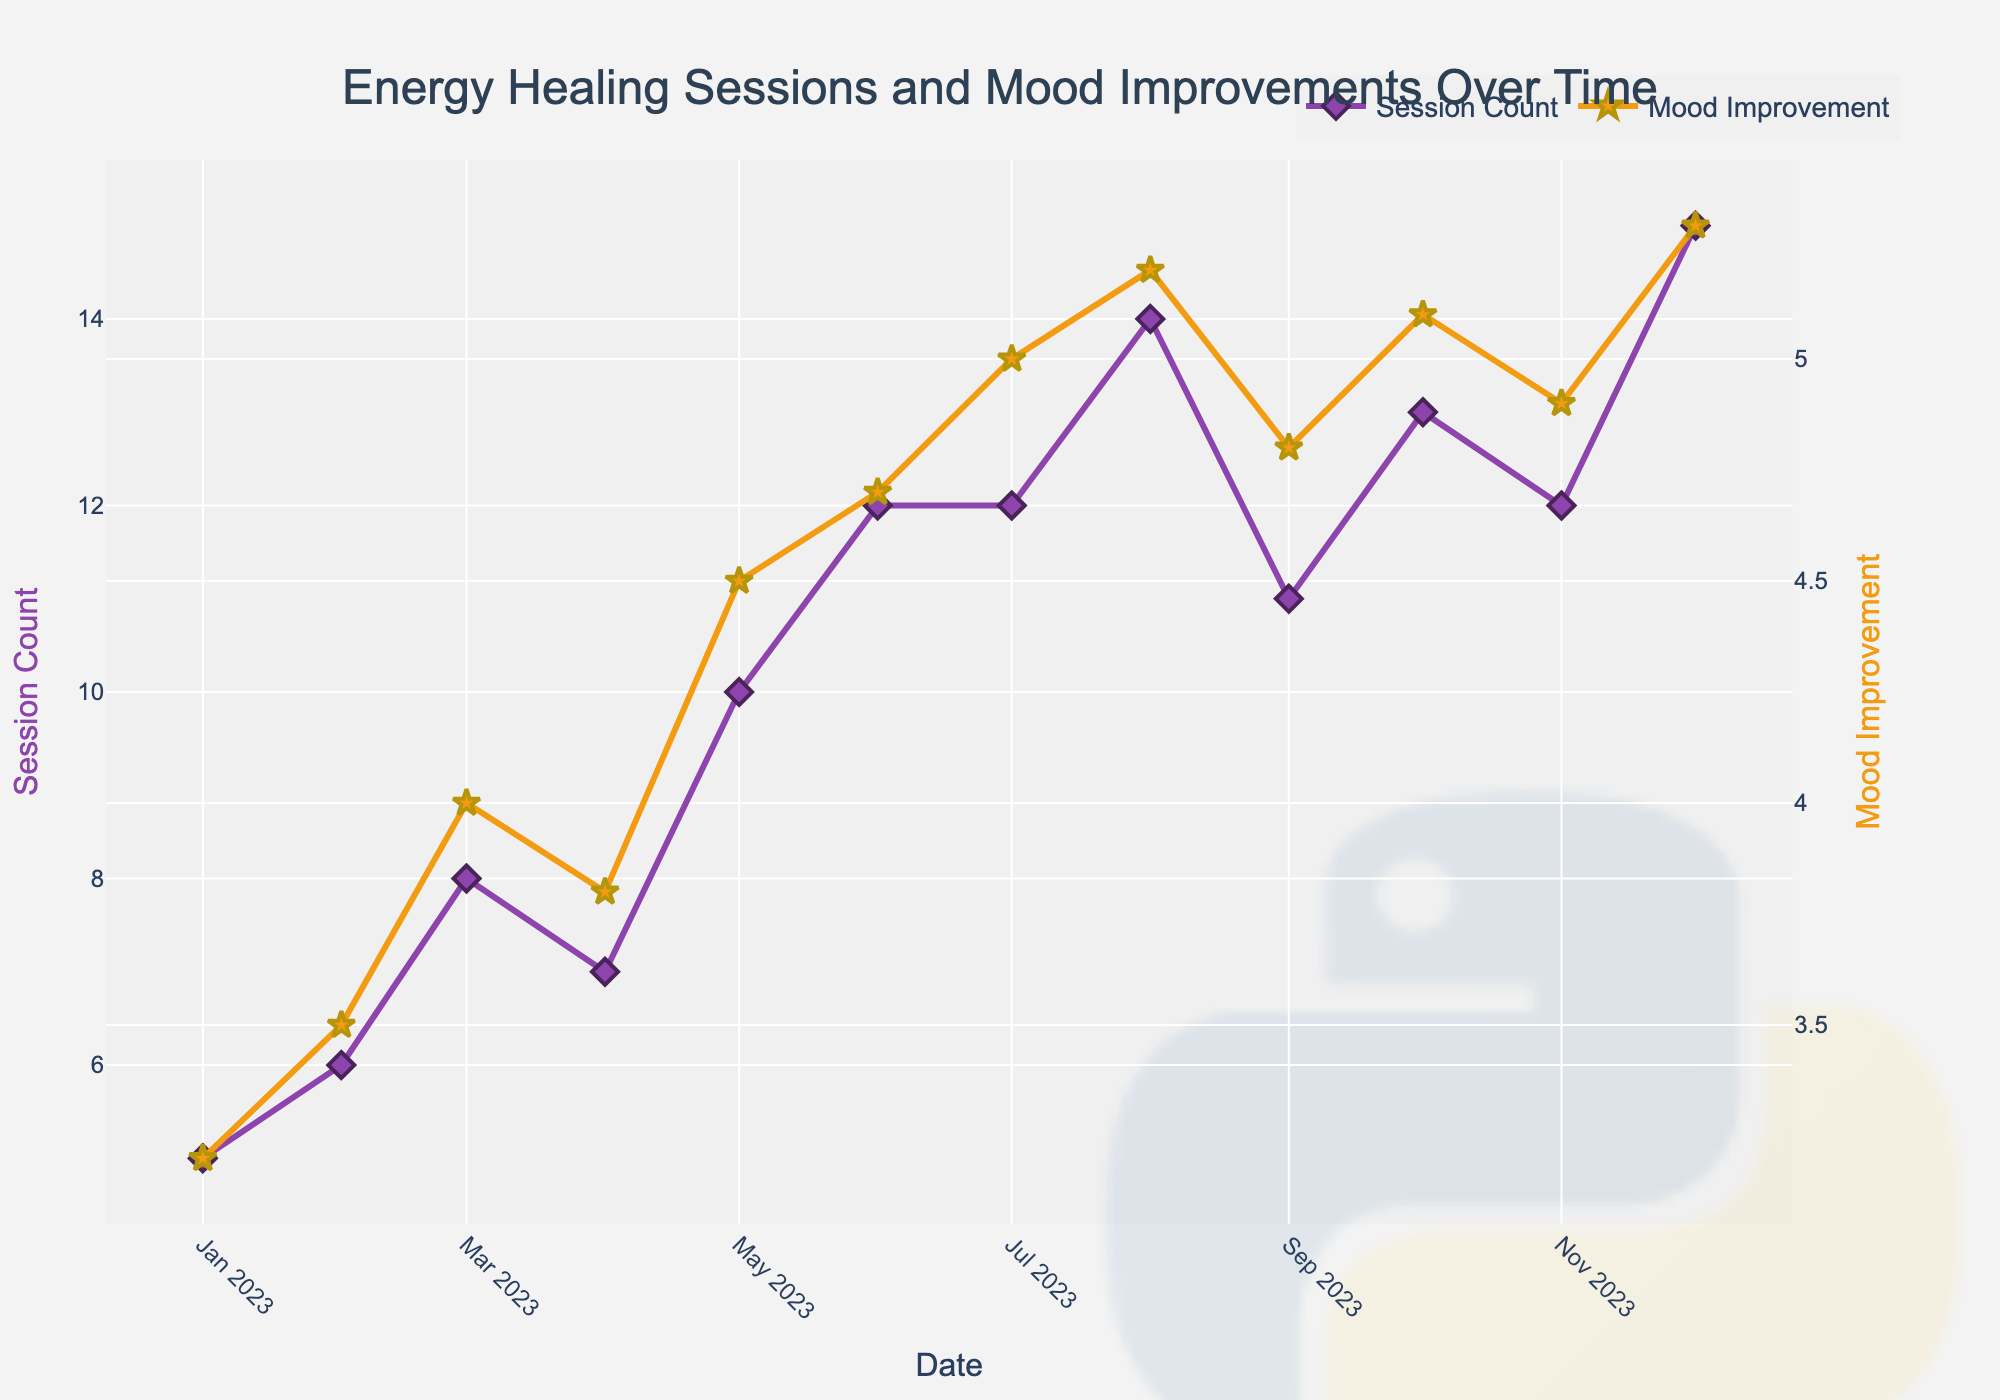How many data points are there in the plot? Count the number of data points on the x-axis (Date). Each month from January to December represents a data point.
Answer: 12 Which month has the highest session count? By observing the peaks on the Session Count line, it is apparent that December has the highest point.
Answer: December What is the title of the plot? The title is displayed at the top of the plot. It reads "Energy Healing Sessions and Mood Improvements Over Time."
Answer: Energy Healing Sessions and Mood Improvements Over Time What is the color of the line representing Mood Improvement? The Mood Improvement line is shown in a bright color distinct from Session Count, specifically in a shade of vibrant orange.
Answer: Orange What is the average mood improvement from June to December? Sum the Mood Improvement values from June (4.7), July (5.0), August (5.2), September (4.8), October (5.1), November (4.9), and December (5.3), then divide by the number of months (7). Calculation: (4.7 + 5.0 + 5.2 + 4.8 + 5.1 + 4.9 + 5.3) / 7 = 35 / 7 = 5.0
Answer: 5.0 How does the session count in August compare to that in May? Compare the session counts in August (14) and May (10). August has a higher session count.
Answer: Higher Was there a general trend of increasing or decreasing session counts from January to December? By observing the Session Count line's general direction, it shows an upward trend with fluctuations, indicating an overall increase from January to December.
Answer: Increasing Which month saw a drop in mood improvement compared to the previous month? Observe the Mood Improvement line for any downward dips. September has a lower value than August (4.8 compared to 5.2).
Answer: September In which month was the mood improvement exactly 4.5? Scan through the Mood Improvement points to find where the value is 4.5. It is observed in May.
Answer: May What is the primary y-axis title? The title of the primary y-axis, which corresponds with Session Count, is indicated on the left and reads "Session Count."
Answer: Session Count 